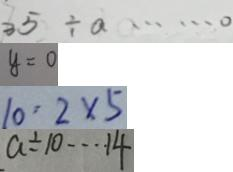Convert formula to latex. <formula><loc_0><loc_0><loc_500><loc_500>3 5 \div a \cdots 0 
 y = 0 
 1 0 : 2 \times 5 
 a \div 1 0 \cdots 1 4</formula> 